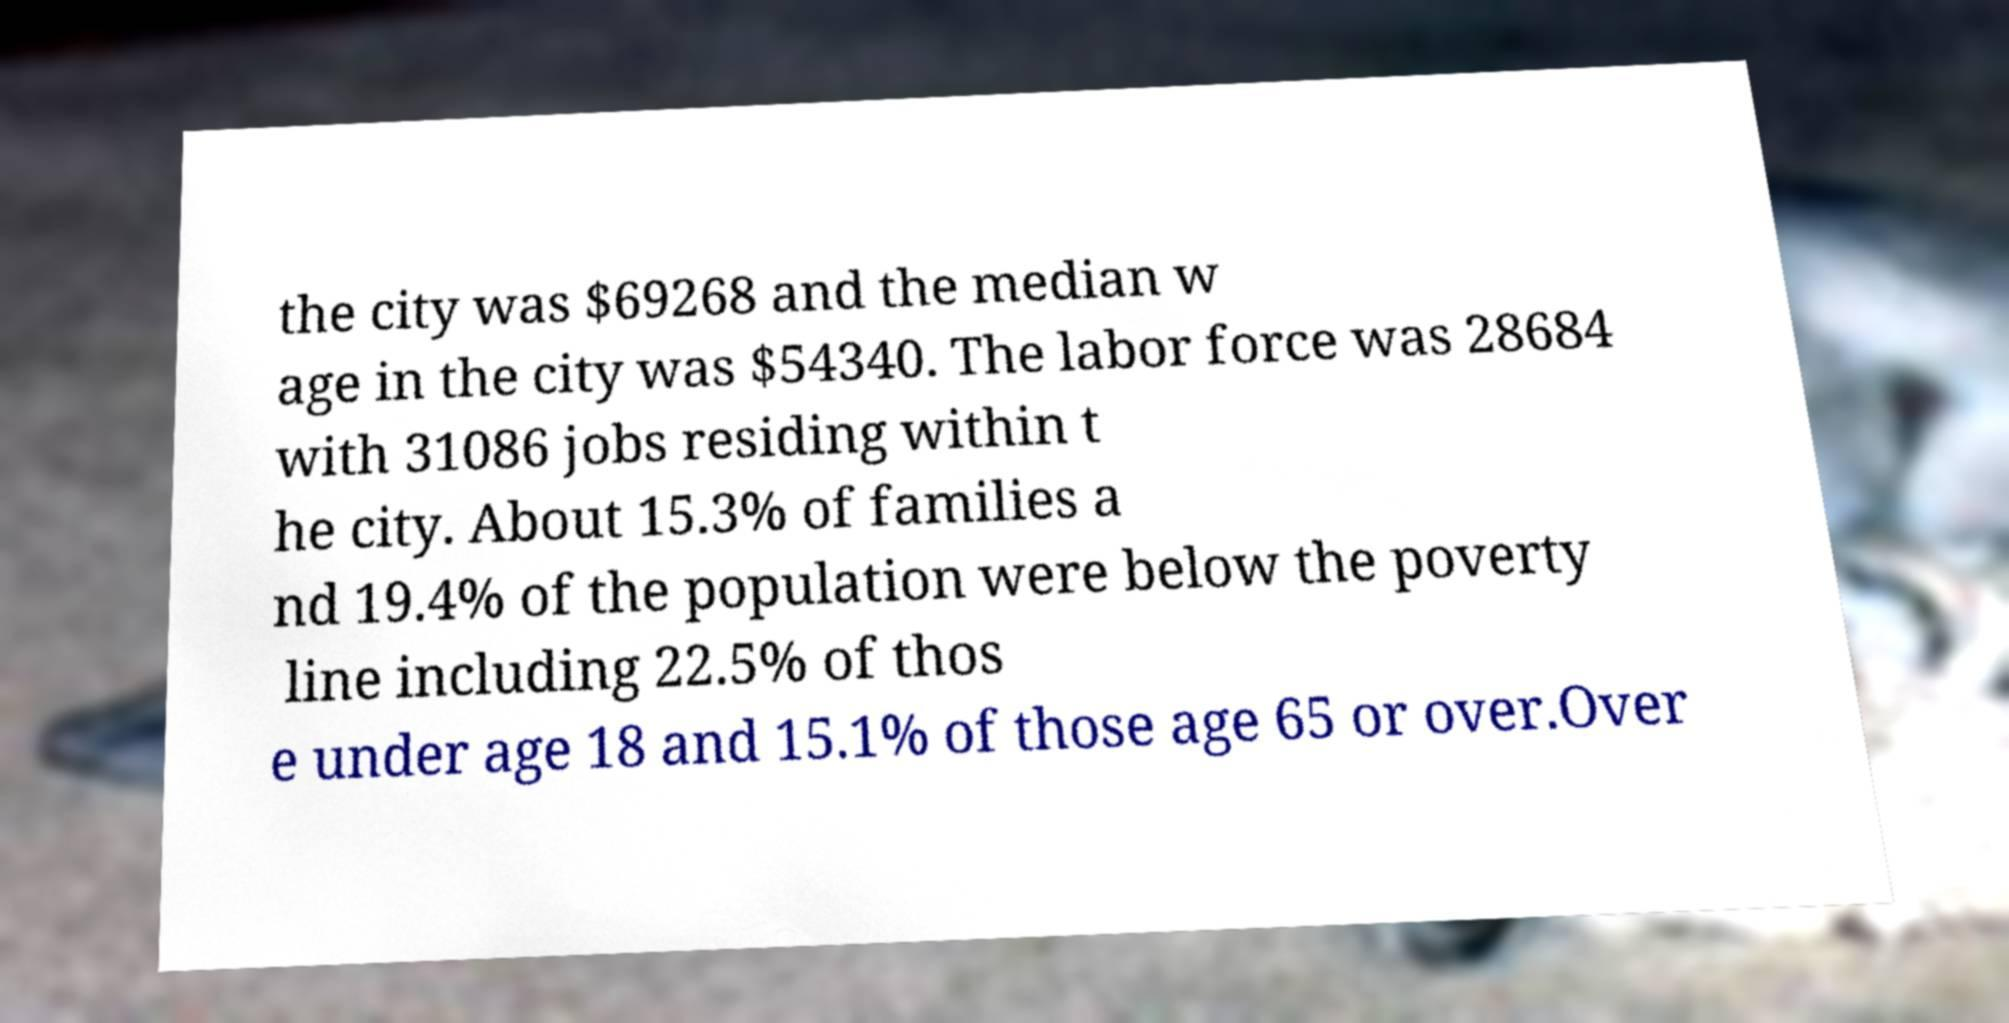There's text embedded in this image that I need extracted. Can you transcribe it verbatim? the city was $69268 and the median w age in the city was $54340. The labor force was 28684 with 31086 jobs residing within t he city. About 15.3% of families a nd 19.4% of the population were below the poverty line including 22.5% of thos e under age 18 and 15.1% of those age 65 or over.Over 